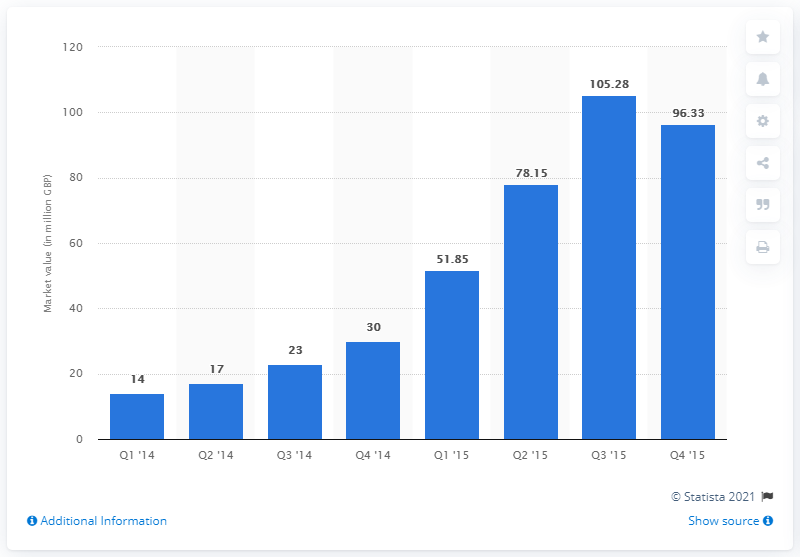Specify some key components in this picture. The market value of equity trading in the first quarter of 2014 was 14... According to the information provided, the market value of equity trading in the same quarter of 2015 was approximately 51.85. 